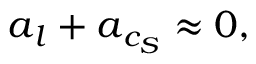<formula> <loc_0><loc_0><loc_500><loc_500>a _ { l } + a _ { c _ { S } } \approx 0 ,</formula> 